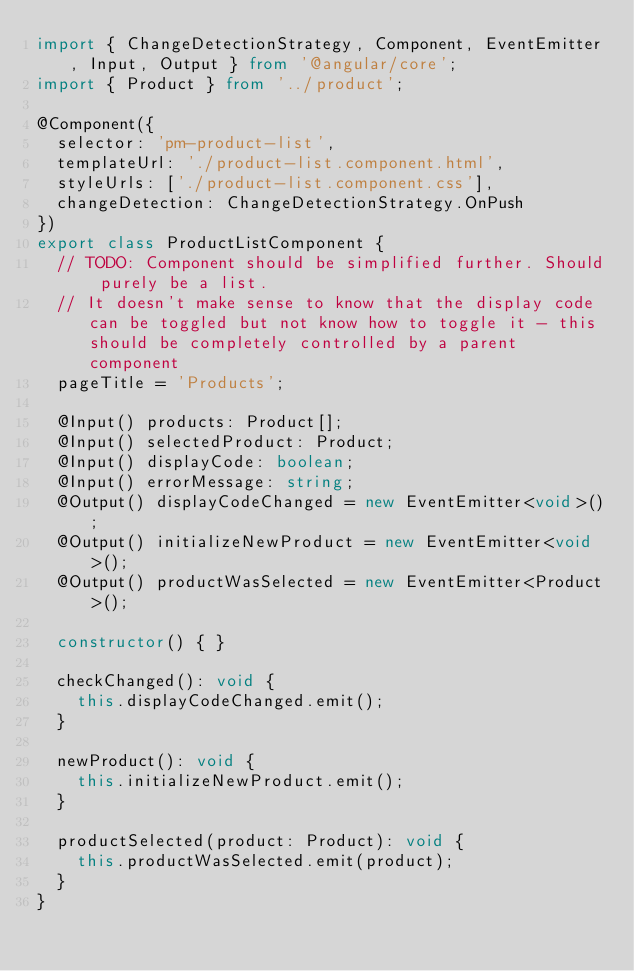<code> <loc_0><loc_0><loc_500><loc_500><_TypeScript_>import { ChangeDetectionStrategy, Component, EventEmitter, Input, Output } from '@angular/core';
import { Product } from '../product';

@Component({
  selector: 'pm-product-list',
  templateUrl: './product-list.component.html',
  styleUrls: ['./product-list.component.css'],
  changeDetection: ChangeDetectionStrategy.OnPush
})
export class ProductListComponent {
  // TODO: Component should be simplified further. Should purely be a list.
  // It doesn't make sense to know that the display code can be toggled but not know how to toggle it - this should be completely controlled by a parent component
  pageTitle = 'Products';

  @Input() products: Product[];
  @Input() selectedProduct: Product;
  @Input() displayCode: boolean;
  @Input() errorMessage: string;
  @Output() displayCodeChanged = new EventEmitter<void>();
  @Output() initializeNewProduct = new EventEmitter<void>();
  @Output() productWasSelected = new EventEmitter<Product>();

  constructor() { }

  checkChanged(): void {
    this.displayCodeChanged.emit();
  }

  newProduct(): void {
    this.initializeNewProduct.emit();
  }

  productSelected(product: Product): void {
    this.productWasSelected.emit(product);
  }
}
</code> 